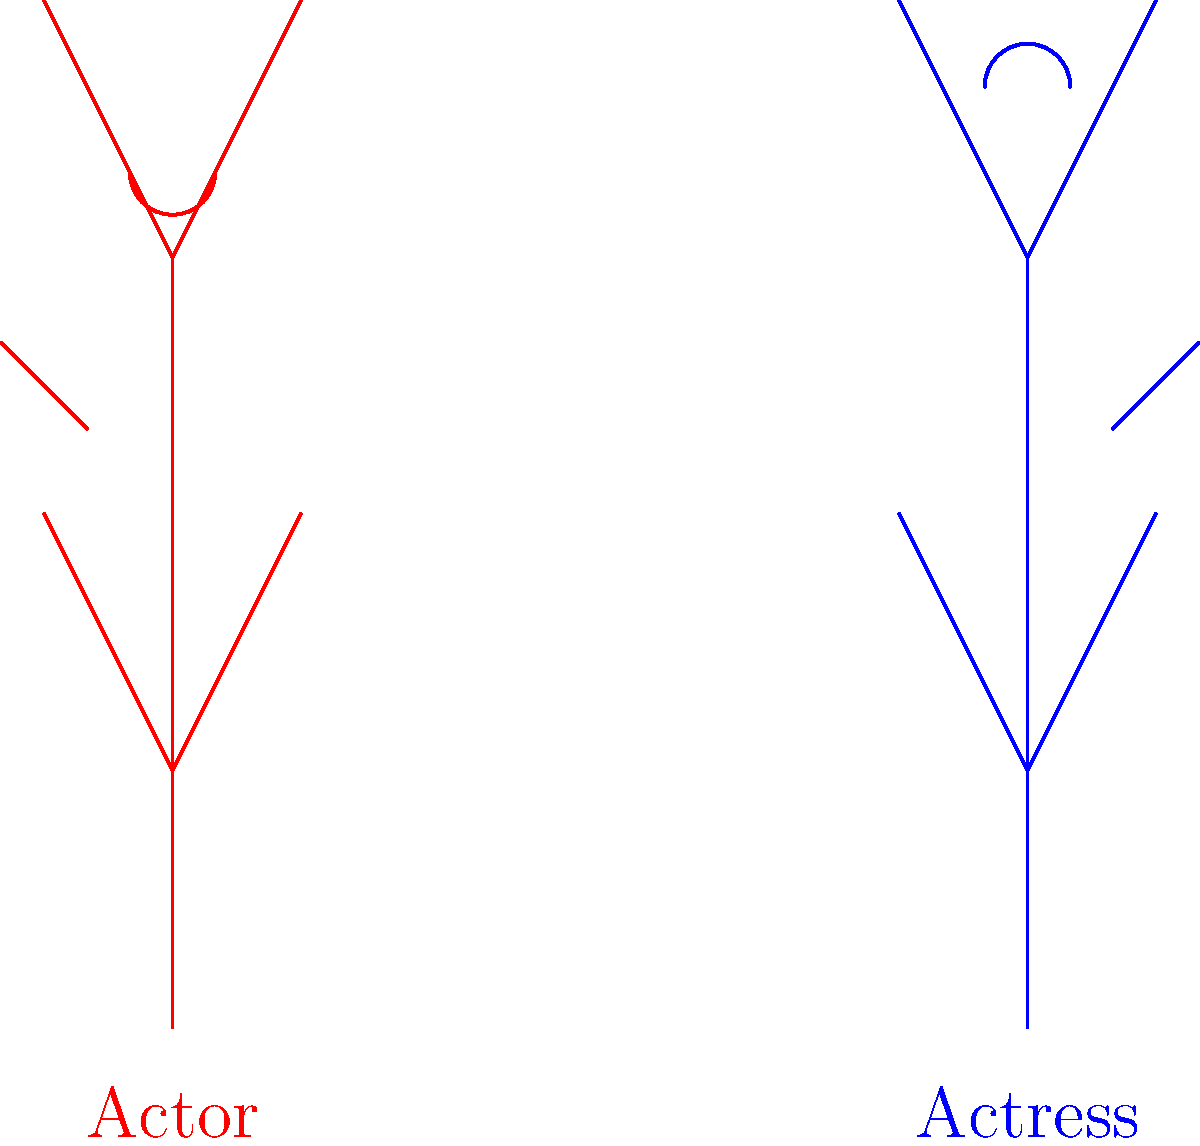In the image above, what does the body language of the actor (in red) suggest about their emotional state towards the actress (in blue)? To interpret the body language in this image, let's analyze it step by step:

1. Posture: The actor's stick figure is slightly leaning away from the actress, indicating a sense of distance or withdrawal.

2. Arms: The actor's arms are angled slightly downward and away from the body, which can suggest defensiveness or discomfort.

3. Head: The actor's head is tilted slightly downward, potentially indicating low confidence or negative emotions.

4. Facial expression: The actor's mouth is drawn in a downward curve, suggesting a frown or unhappy expression.

5. Comparison to the actress: The actress's stick figure has a more open posture, with arms angled upward and a smile, contrasting with the actor's closed-off body language.

6. Overall impression: The actor's body language collectively suggests feelings of discomfort, insecurity, and possibly resentment or envy towards the actress.

Given the persona of a struggling actor who feels envious of the actress's success and harbors mixed feelings about their relationship, this body language aligns with those emotions. The actor appears to be physically expressing their internal conflict and negative feelings towards the actress's success.
Answer: Discomfort and envy 